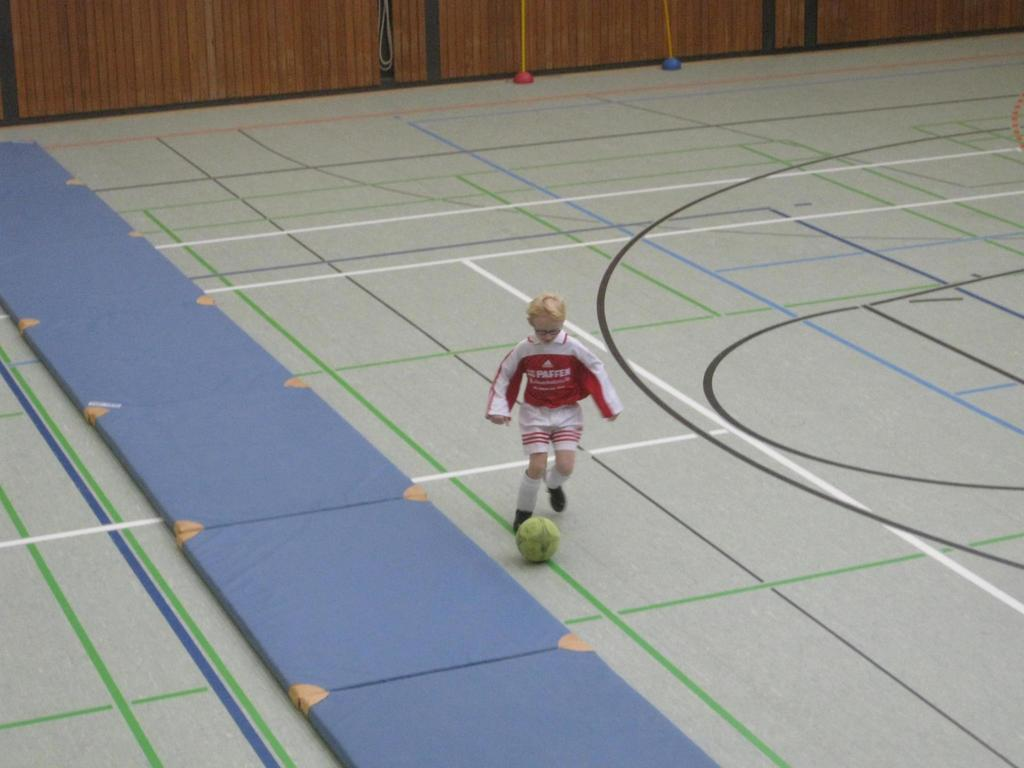<image>
Summarize the visual content of the image. a boy in an indoor gym kicks a ball in a Passen jersey 